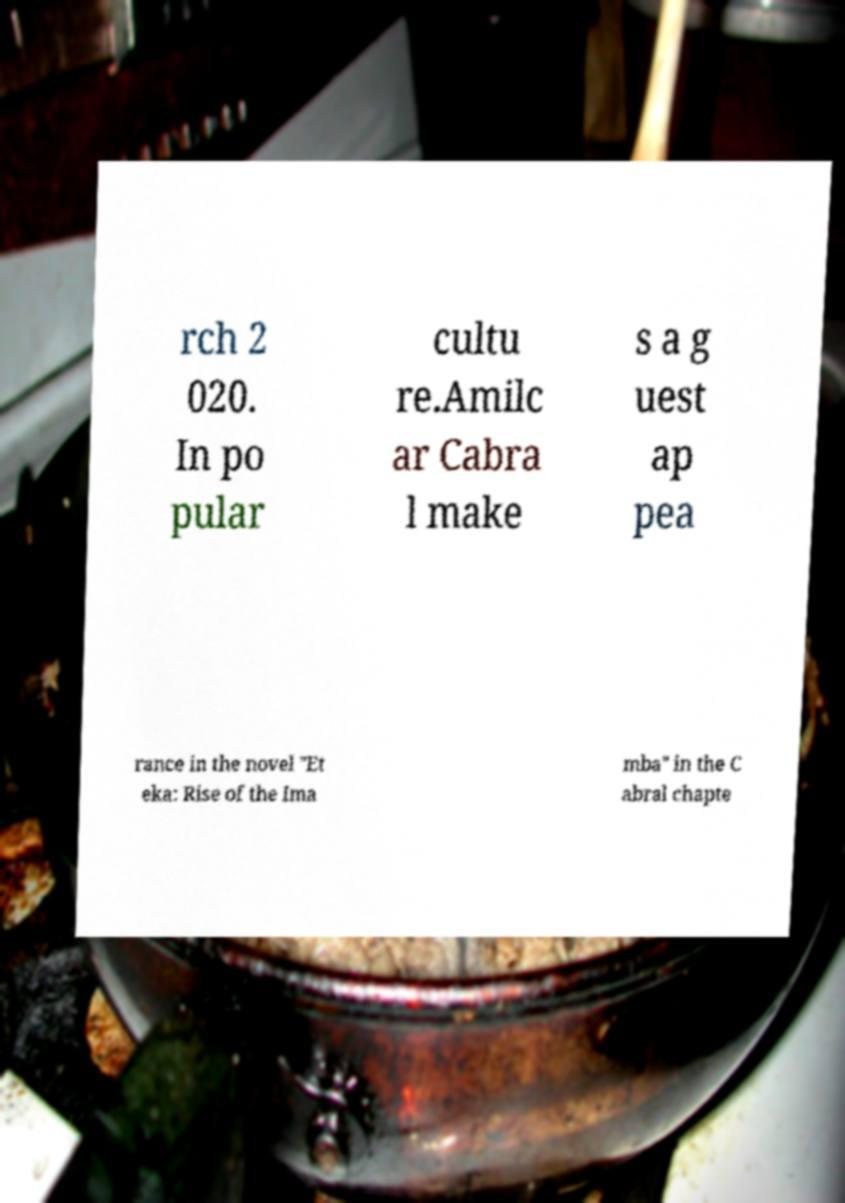Could you assist in decoding the text presented in this image and type it out clearly? rch 2 020. In po pular cultu re.Amilc ar Cabra l make s a g uest ap pea rance in the novel "Et eka: Rise of the Ima mba" in the C abral chapte 